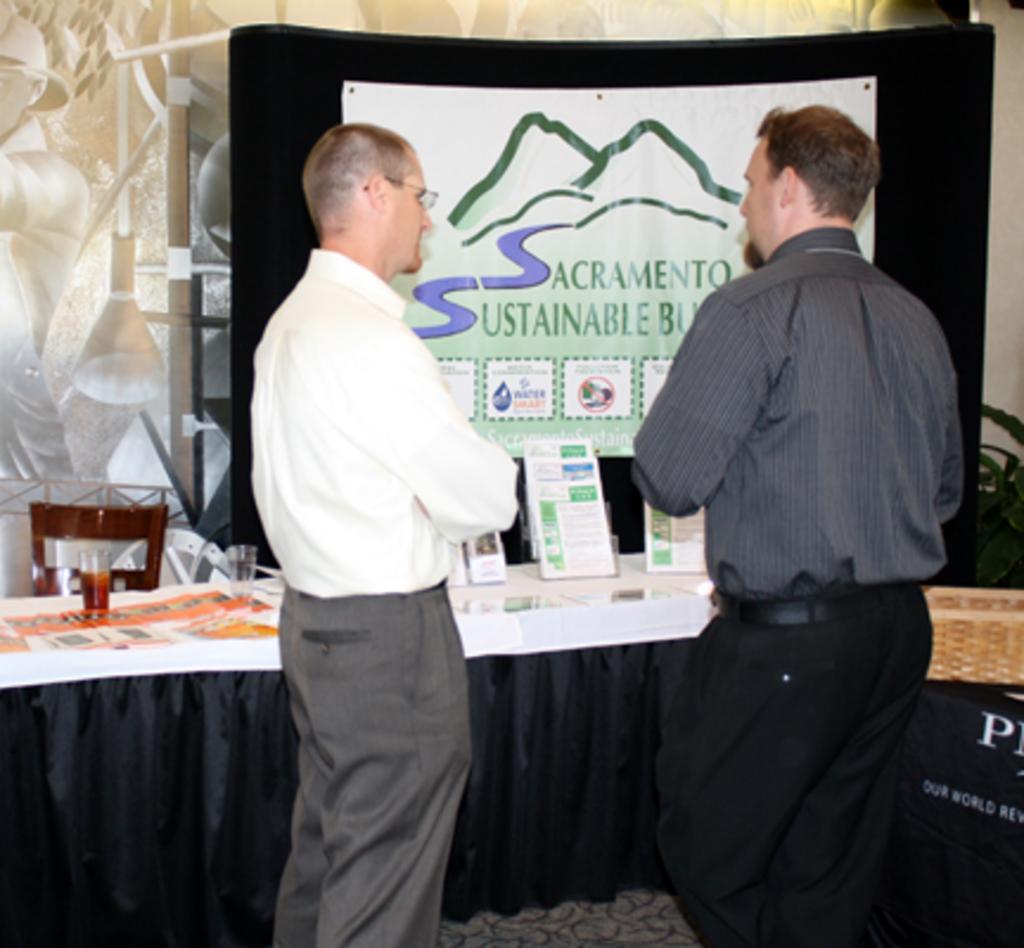How would you summarize this image in a sentence or two? there are two persons standing in front of a table and talking 